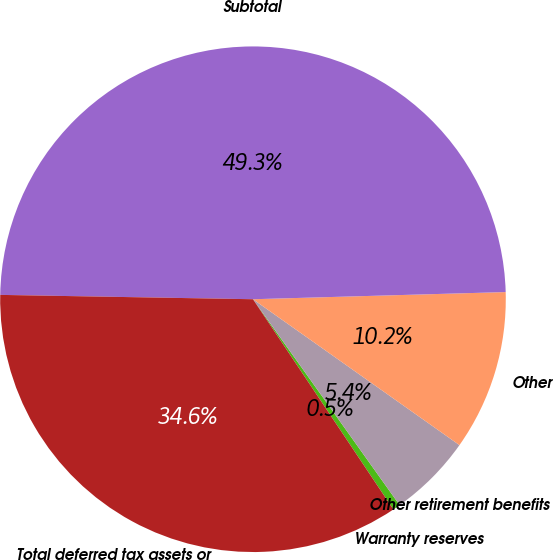Convert chart to OTSL. <chart><loc_0><loc_0><loc_500><loc_500><pie_chart><fcel>Warranty reserves<fcel>Other retirement benefits<fcel>Other<fcel>Subtotal<fcel>Total deferred tax assets or<nl><fcel>0.48%<fcel>5.36%<fcel>10.24%<fcel>49.27%<fcel>34.64%<nl></chart> 